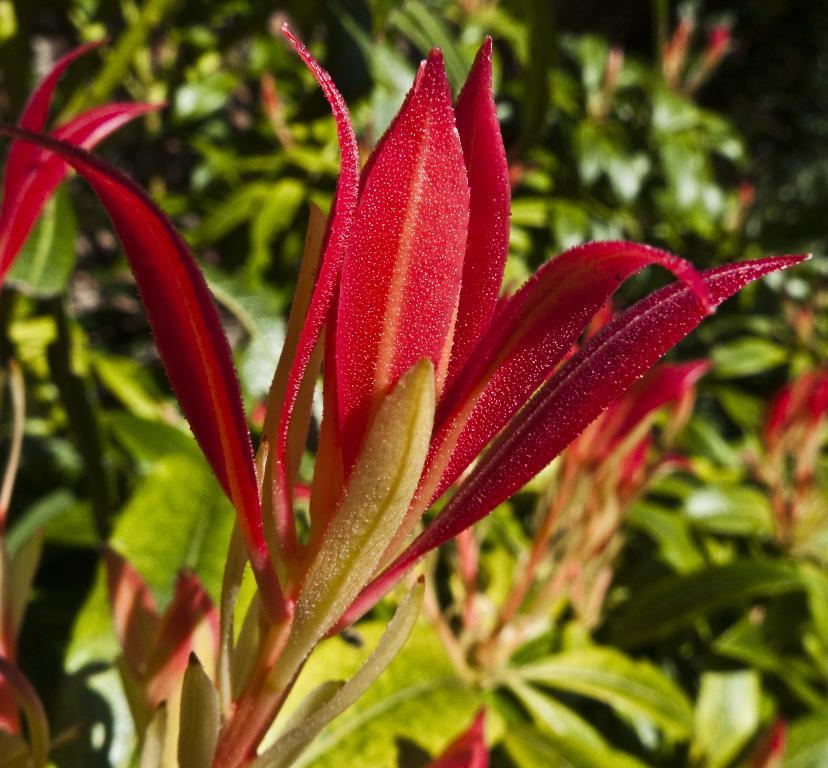Please provide a concise description of this image. In the middle of the image, there is a red color flower of a plant. In the background, there are plants having green color leaves. Some of them are having flowers. 